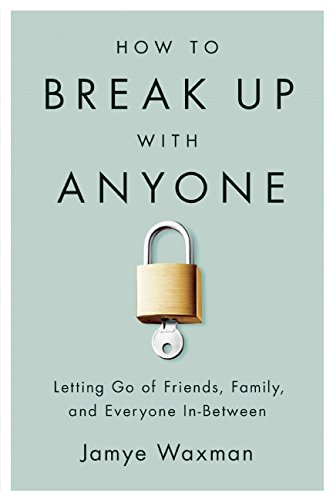Who wrote this book? The book 'How to Break Up With Anyone: Letting Go of Friends, Family, and Everyone In-Between' is penned by Jamye Waxman. 